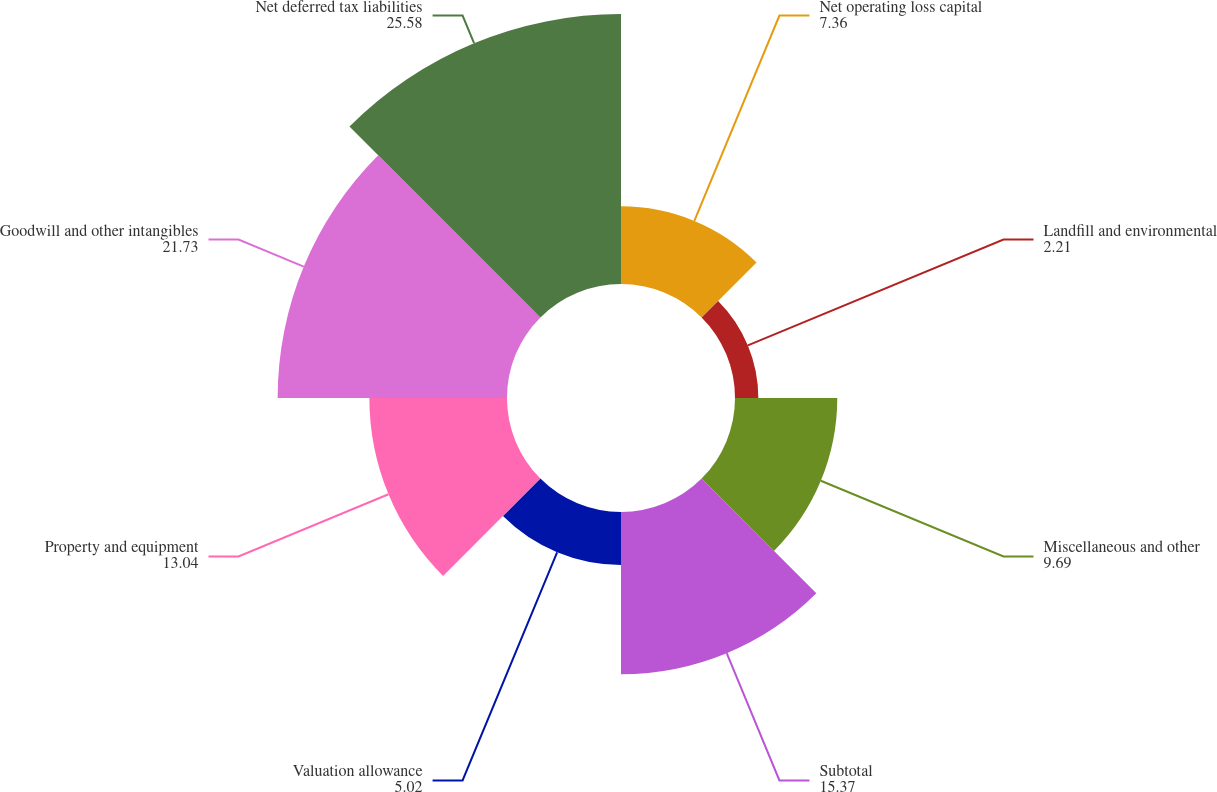<chart> <loc_0><loc_0><loc_500><loc_500><pie_chart><fcel>Net operating loss capital<fcel>Landfill and environmental<fcel>Miscellaneous and other<fcel>Subtotal<fcel>Valuation allowance<fcel>Property and equipment<fcel>Goodwill and other intangibles<fcel>Net deferred tax liabilities<nl><fcel>7.36%<fcel>2.21%<fcel>9.69%<fcel>15.37%<fcel>5.02%<fcel>13.04%<fcel>21.73%<fcel>25.58%<nl></chart> 